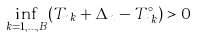<formula> <loc_0><loc_0><loc_500><loc_500>\inf _ { k = 1 , \dots , B } ( T _ { n k } + \Delta _ { n } - T _ { n k } ^ { \circ } ) > 0</formula> 